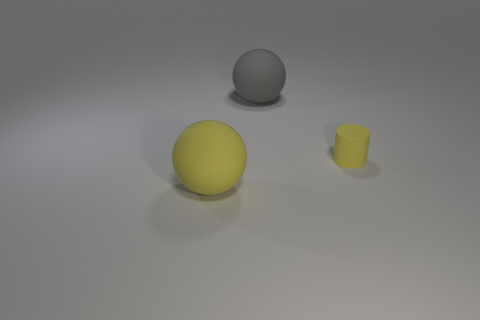Add 1 spheres. How many objects exist? 4 Subtract all balls. How many objects are left? 1 Add 1 small shiny balls. How many small shiny balls exist? 1 Subtract 0 purple spheres. How many objects are left? 3 Subtract all yellow rubber objects. Subtract all gray rubber objects. How many objects are left? 0 Add 2 tiny cylinders. How many tiny cylinders are left? 3 